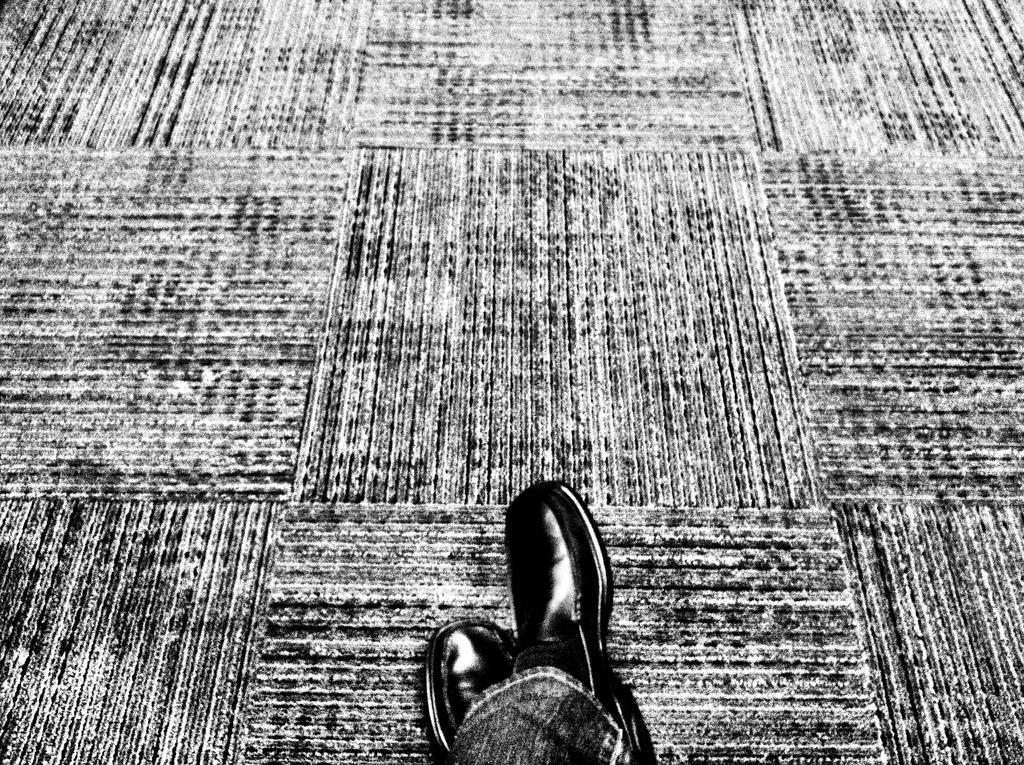Describe this image in one or two sentences. In this image we can see the legs of the person on the floor. 